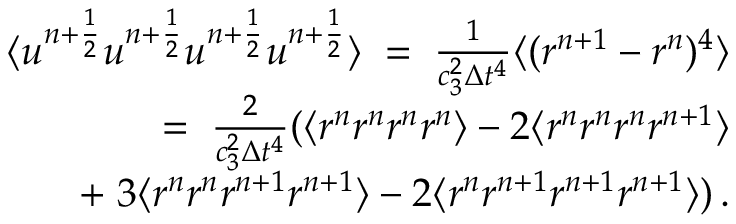<formula> <loc_0><loc_0><loc_500><loc_500>\begin{array} { r l r } & { \langle u ^ { n + \frac { 1 } { 2 } } u ^ { n + \frac { 1 } { 2 } } u ^ { n + \frac { 1 } { 2 } } u ^ { n + \frac { 1 } { 2 } } \rangle \, = \, \frac { 1 } { c _ { 3 } ^ { 2 } \Delta { t } ^ { 4 } } \langle ( r ^ { n + 1 } - r ^ { n } ) ^ { 4 } \rangle } \\ & { = \, \frac { 2 } { c _ { 3 } ^ { 2 } \Delta { t } ^ { 4 } } ( \langle r ^ { n } r ^ { n } r ^ { n } r ^ { n } \rangle - 2 \langle r ^ { n } r ^ { n } r ^ { n } r ^ { n + 1 } \rangle } \\ & { + \, 3 \langle r ^ { n } r ^ { n } r ^ { n + 1 } r ^ { n + 1 } \rangle - 2 \langle r ^ { n } r ^ { n + 1 } r ^ { n + 1 } r ^ { n + 1 } \rangle ) \, . } \end{array}</formula> 